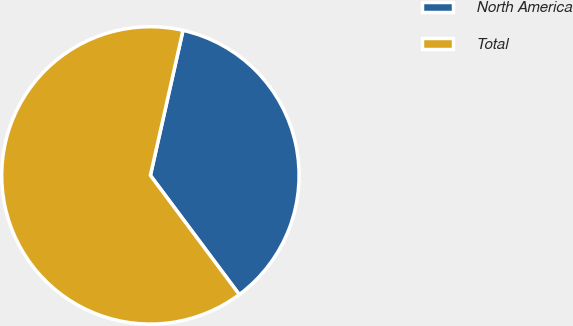<chart> <loc_0><loc_0><loc_500><loc_500><pie_chart><fcel>North America<fcel>Total<nl><fcel>36.28%<fcel>63.72%<nl></chart> 